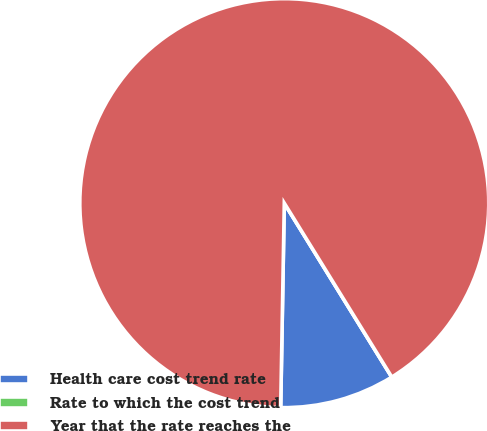Convert chart. <chart><loc_0><loc_0><loc_500><loc_500><pie_chart><fcel>Health care cost trend rate<fcel>Rate to which the cost trend<fcel>Year that the rate reaches the<nl><fcel>9.09%<fcel>0.0%<fcel>90.91%<nl></chart> 